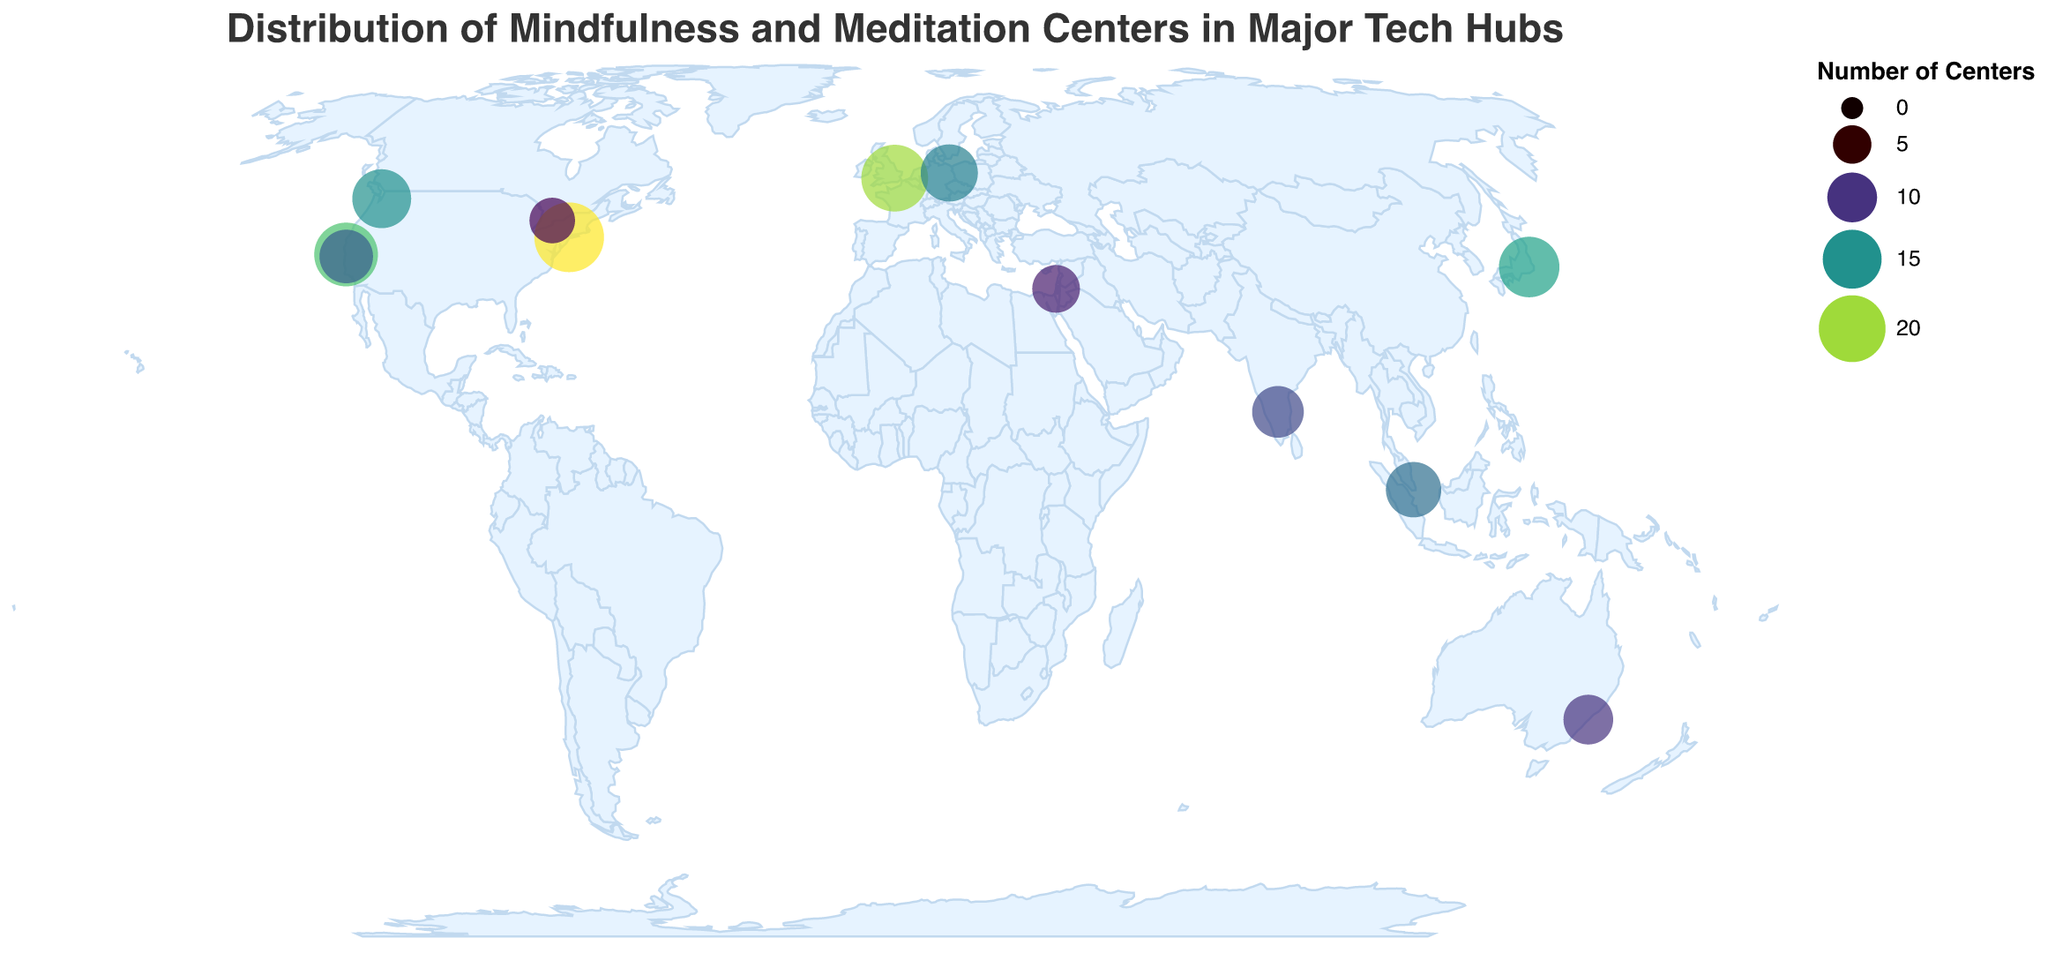What is the title of the plot? The title of the plot is displayed at the top and reads "Distribution of Mindfulness and Meditation Centers in Major Tech Hubs".
Answer: Distribution of Mindfulness and Meditation Centers in Major Tech Hubs Which city has the highest number of mindfulness centers? By looking at the colored circles, the size and color intensity indicate the number of centers. New York has the largest and darkest circle.
Answer: New York Which cities have fewer than 10 mindfulness centers? We need to identify circles that are smaller and lighter. The cities with fewer than 10 centers are Tel Aviv (9) and Toronto (8).
Answer: Tel Aviv, Toronto How many mindfulness centers are there in total across all the cities? Add the number of centers from each city: 18 (San Francisco) + 12 (Palo Alto) + 15 (Seattle) + 22 (New York) + 20 (London) + 14 (Berlin) + 9 (Tel Aviv) + 11 (Bangalore) + 16 (Tokyo) + 13 (Singapore) + 10 (Sydney) + 8 (Toronto) = 168
Answer: 168 Which city has more mindfulness centers, Palo Alto or Toronto? Compare the number of centers between Palo Alto (12) and Toronto (8). Palo Alto has more centers.
Answer: Palo Alto What is the average number of mindfulness centers in the listed cities? The total number of centers is 168, and there are 12 cities. The average is 168 / 12 = 14.
Answer: 14 What city has the closest number of mindfulness centers to the average? The average number of centers is 14. Cities with numbers close to 14 are Seattle (15) and Berlin (14). Berlin is exactly at the average.
Answer: Berlin Which country has the most cities represented in the plot? The countries represented can be counted. The USA has multiple cities: San Francisco, Palo Alto, Seattle, and New York.
Answer: USA What is the color scheme used for representing the number of mindfulness centers? The figure uses a color scale from light to dark as indicated by the legend, and it follows the "viridis" color scheme.
Answer: Viridis What geographic region has the densest concentration of mindfulness centers? By observing the cluster of circles, the densest concentration appears in the United States: San Francisco, Palo Alto, Seattle, and New York.
Answer: United States 